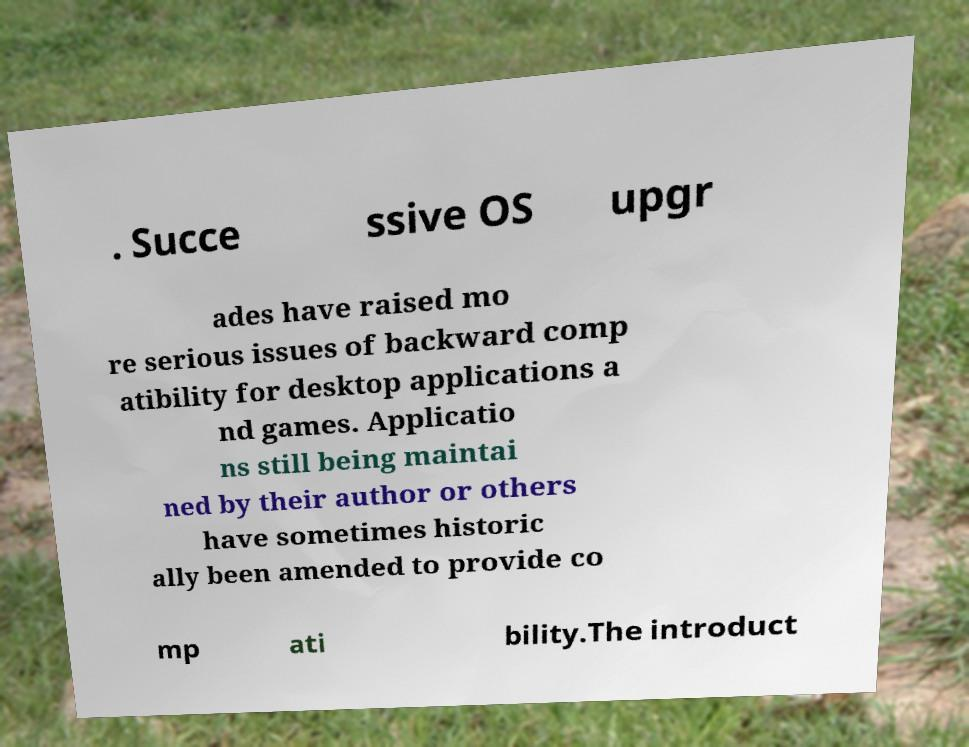Please read and relay the text visible in this image. What does it say? . Succe ssive OS upgr ades have raised mo re serious issues of backward comp atibility for desktop applications a nd games. Applicatio ns still being maintai ned by their author or others have sometimes historic ally been amended to provide co mp ati bility.The introduct 